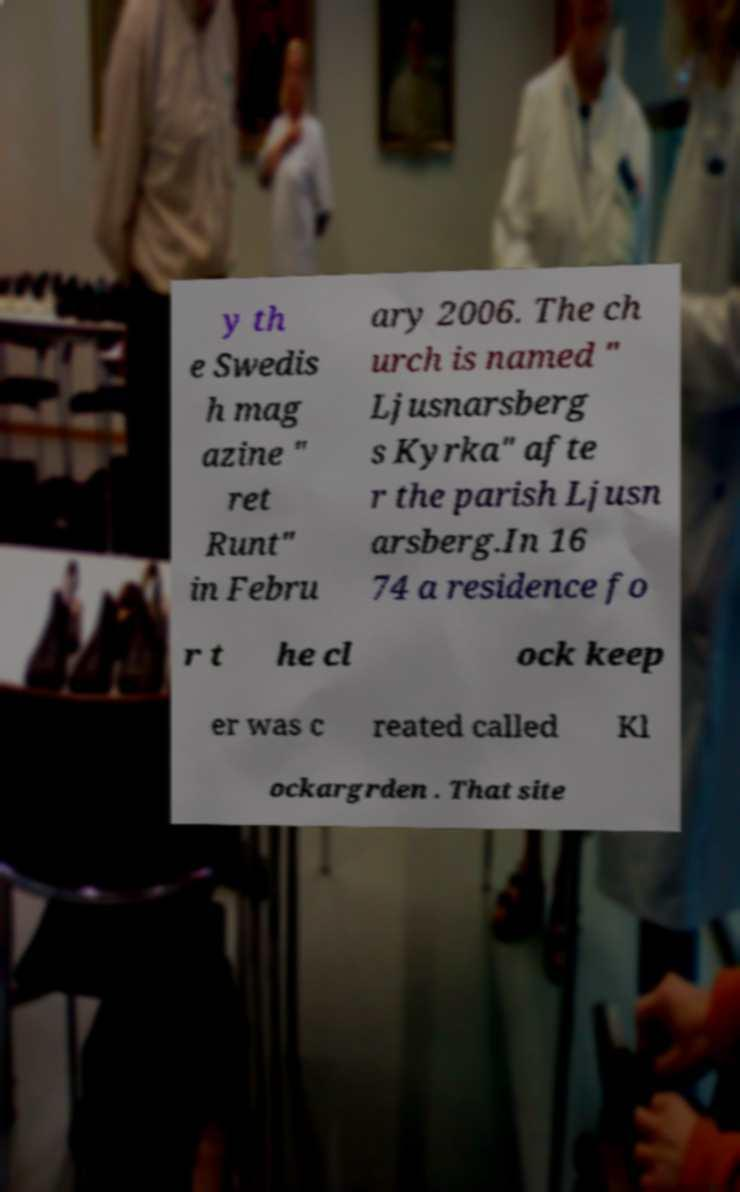Please identify and transcribe the text found in this image. y th e Swedis h mag azine " ret Runt" in Febru ary 2006. The ch urch is named " Ljusnarsberg s Kyrka" afte r the parish Ljusn arsberg.In 16 74 a residence fo r t he cl ock keep er was c reated called Kl ockargrden . That site 